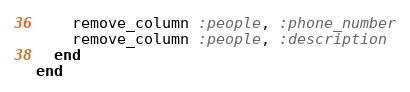Convert code to text. <code><loc_0><loc_0><loc_500><loc_500><_Ruby_>    remove_column :people, :phone_number
    remove_column :people, :description
  end
end
</code> 